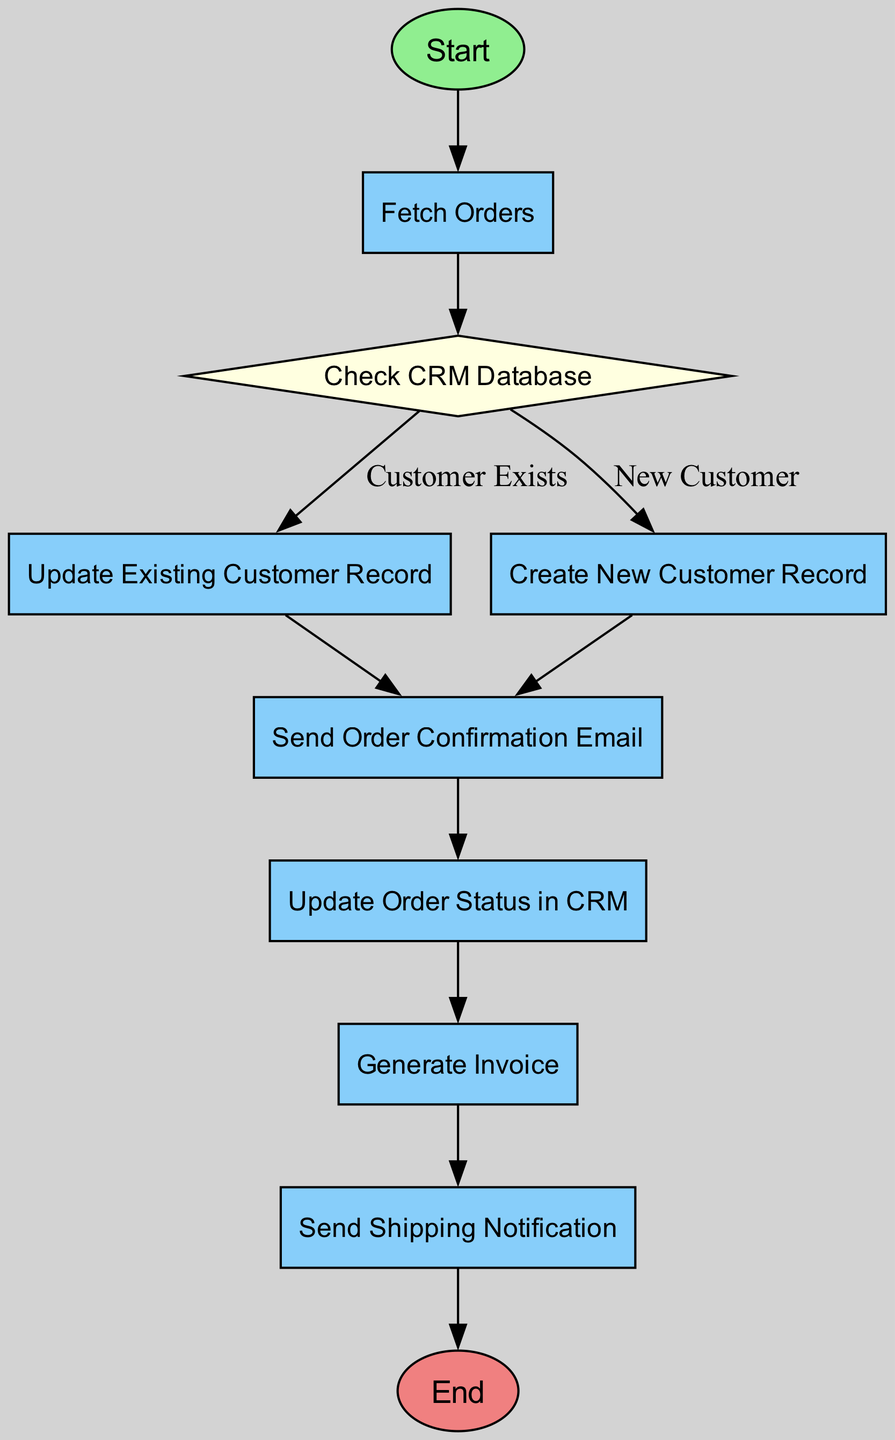What is the starting point of the process? The diagram begins at the node labeled "Start," which signifies the beginning of the CRM Integration process for order tracking and communication.
Answer: Start How many processes are present in the diagram? By counting the nodes classified as 'process,' we identify "Fetch Orders," "Update Existing Customer Record," "Create New Customer Record," "Send Order Confirmation Email," "Update Order Status in CRM," "Generate Invoice," and "Send Shipping Notification," totaling 7 processes.
Answer: 7 Which node follows "Fetch Orders"? The flow continues from "Fetch Orders" to "Check CRM Database," indicating the process of verifying customer details after fetching new orders.
Answer: Check CRM Database What happens if a customer does not exist in the CRM? If the customer is determined to be new (indicated by the decision node), the process leads to "Create New Customer Record," which adds a new entry to the CRM with the order details.
Answer: Create New Customer Record After sending the order confirmation email, which step comes next? The process continues to "Update Order Status in CRM," where the status is set to 'Processing' after the confirmation email is sent.
Answer: Update Order Status in CRM How many decision points are in the diagram? There is one decision node, "Check CRM Database," which leads to two options regarding the existence of the customer in the CRM, thus there is a single decision point present.
Answer: 1 What is the final step of the CRM integration process? The process concludes at the node labeled "End," indicating the completion of the CRM integration operations for order tracking and communication.
Answer: End What type of node is "Check CRM Database"? The node "Check CRM Database" is classified as a decision node, as it involves evaluating whether the customer's details are already in the CRM.
Answer: decision What type of notification is sent after the order has shipped? "Send Shipping Notification" is the process that triggers an automated email to the customer containing tracking information after the order has shipped.
Answer: Shipping Notification 